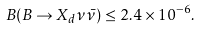Convert formula to latex. <formula><loc_0><loc_0><loc_500><loc_500>B ( B \rightarrow X _ { d } \nu \bar { \nu } ) \leq 2 . 4 \times 1 0 ^ { - 6 } .</formula> 